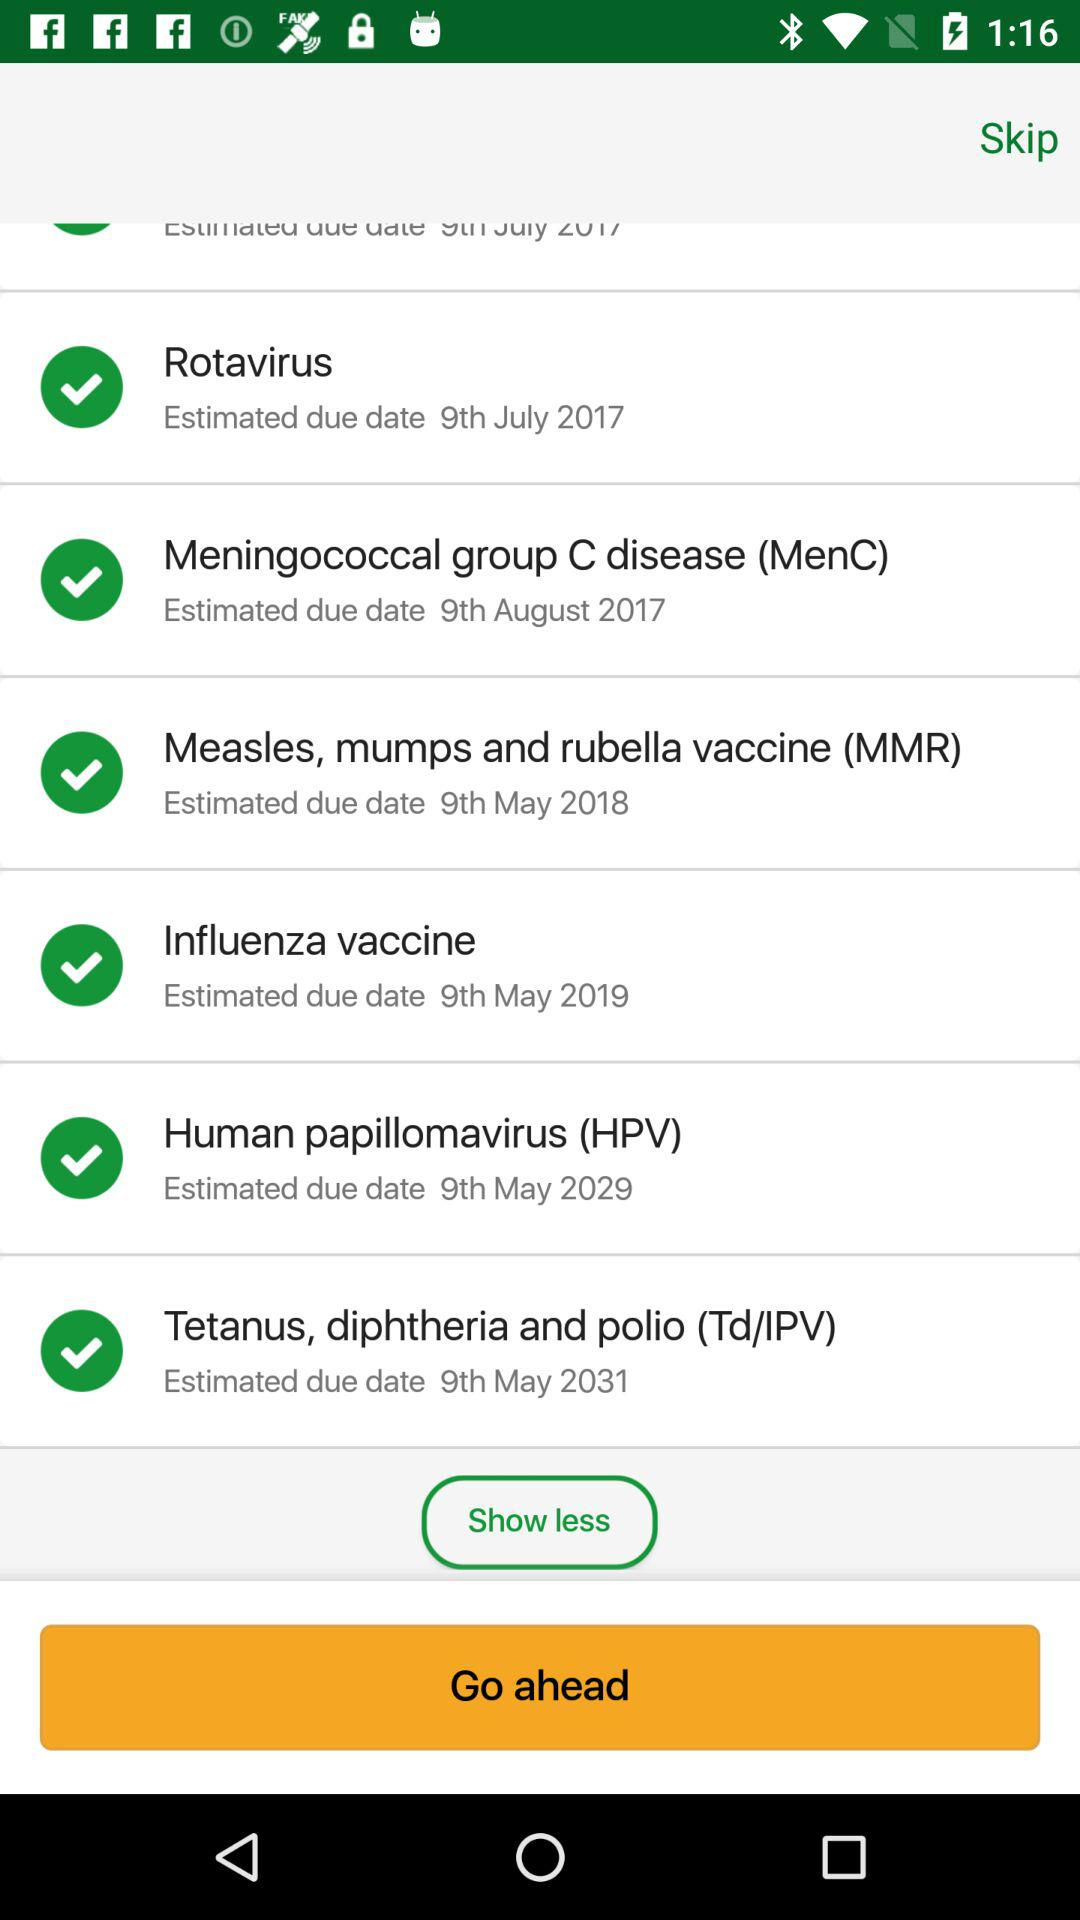Which vaccine's estimated due date is May 9th, 2018? The vaccine that has an estimated due date of May 9th, 2018 is the "Measles, mumps and rubella vaccine (MMR)". 